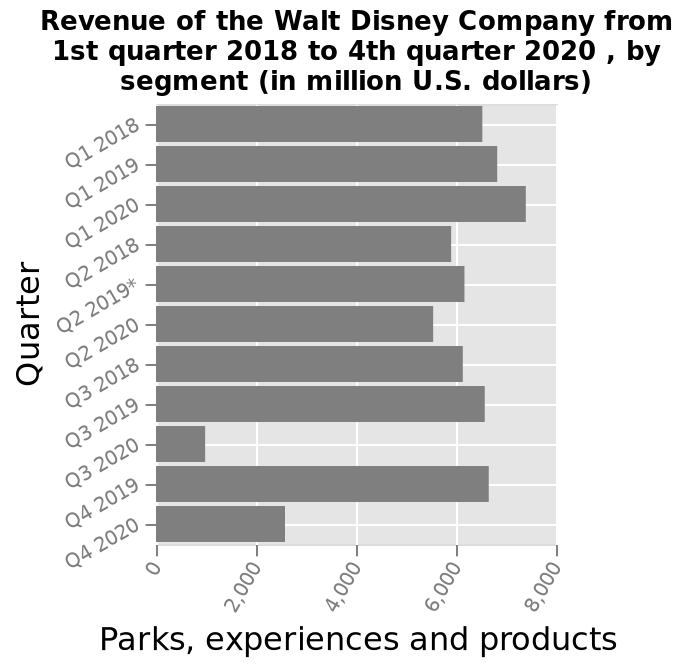<image>
Offer a thorough analysis of the image. Q1 has on average the highest revenue. 2020 has on average the lowest revenue over the year. the lowest revenue recorded was Q3 2020 with under 2,000. The highest Q1 2020. most quarters get around 6,000 revenue. In what units are the values on the diagram represented? The values on the diagram are represented in million U.S. dollars. 